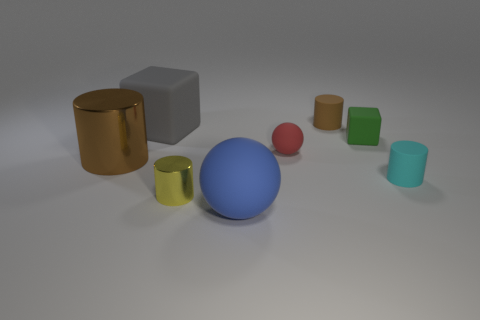Subtract all yellow metallic cylinders. How many cylinders are left? 3 Subtract all blue spheres. How many brown cylinders are left? 2 Subtract all cyan cylinders. How many cylinders are left? 3 Subtract all blue cylinders. Subtract all brown balls. How many cylinders are left? 4 Add 1 small metallic cylinders. How many objects exist? 9 Subtract all balls. How many objects are left? 6 Add 1 blue rubber spheres. How many blue rubber spheres are left? 2 Add 8 rubber cylinders. How many rubber cylinders exist? 10 Subtract 0 gray cylinders. How many objects are left? 8 Subtract all large cyan matte objects. Subtract all yellow metallic cylinders. How many objects are left? 7 